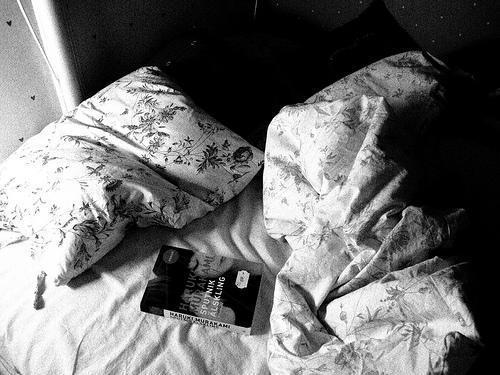How many pillows in picture?
Give a very brief answer. 1. 